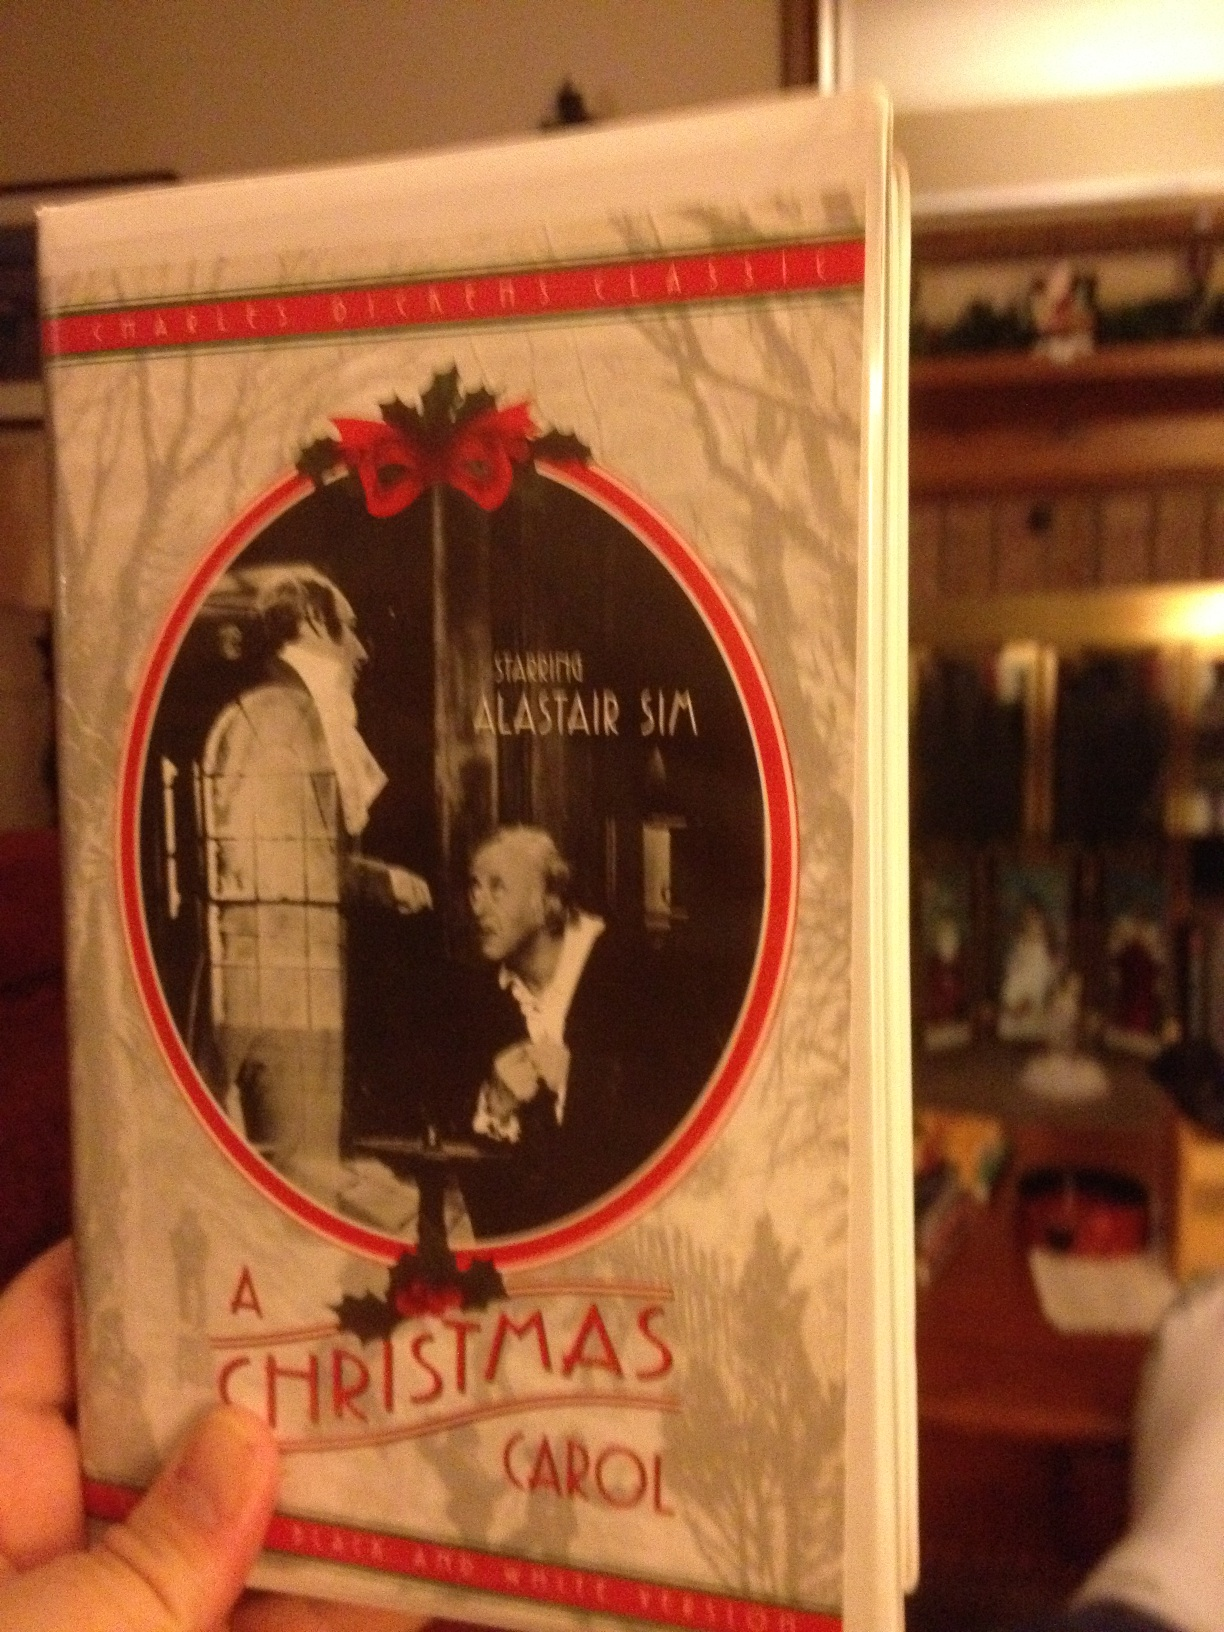Suppose the story of 'A Christmas Carol' was set in a futuristic world where technology dominates, how would the story change? Setting 'A Christmas Carol' in a futuristic world dominated by technology would introduce new dynamics to the classic tale. In this imagined future, Ebenezer Scrooge might be a powerful tech mogul whose life revolves around his wealth, amassed via advanced but ethically questionable business practices. The Ghosts of Christmas Past, Present, and Yet to Come could be depicted as holographic projections or AI entities, each capable of manipulating virtual environments to show Scrooge his memories and potential futures. The futuristic setting might highlight the consequences of technological progress without ethical consideration, adding a layer of commentary on the importance of maintaining humanity and empathy in an increasingly digital world. As Scrooge's transformation unfolds, it could reflect on themes of reconnecting with human values and finding balance between technological advancement and the well-being of society. 